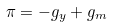<formula> <loc_0><loc_0><loc_500><loc_500>\pi = - g _ { y } + g _ { m }</formula> 